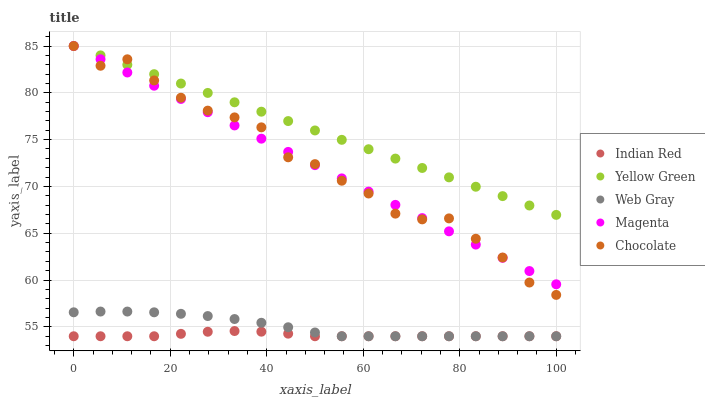Does Indian Red have the minimum area under the curve?
Answer yes or no. Yes. Does Yellow Green have the maximum area under the curve?
Answer yes or no. Yes. Does Web Gray have the minimum area under the curve?
Answer yes or no. No. Does Web Gray have the maximum area under the curve?
Answer yes or no. No. Is Magenta the smoothest?
Answer yes or no. Yes. Is Chocolate the roughest?
Answer yes or no. Yes. Is Web Gray the smoothest?
Answer yes or no. No. Is Web Gray the roughest?
Answer yes or no. No. Does Web Gray have the lowest value?
Answer yes or no. Yes. Does Yellow Green have the lowest value?
Answer yes or no. No. Does Chocolate have the highest value?
Answer yes or no. Yes. Does Web Gray have the highest value?
Answer yes or no. No. Is Indian Red less than Magenta?
Answer yes or no. Yes. Is Magenta greater than Web Gray?
Answer yes or no. Yes. Does Magenta intersect Chocolate?
Answer yes or no. Yes. Is Magenta less than Chocolate?
Answer yes or no. No. Is Magenta greater than Chocolate?
Answer yes or no. No. Does Indian Red intersect Magenta?
Answer yes or no. No. 